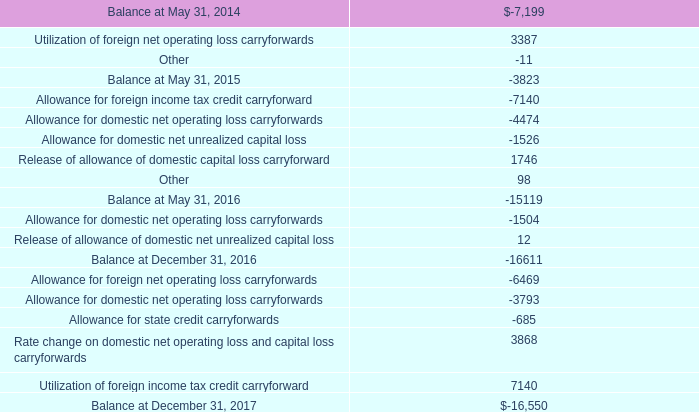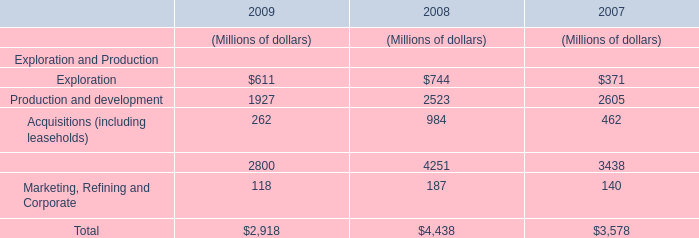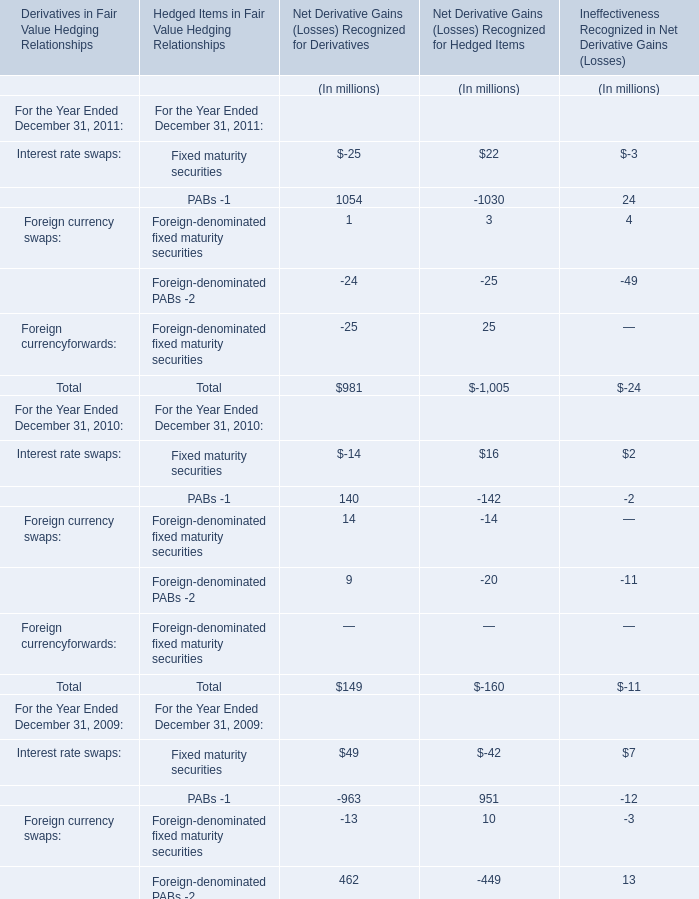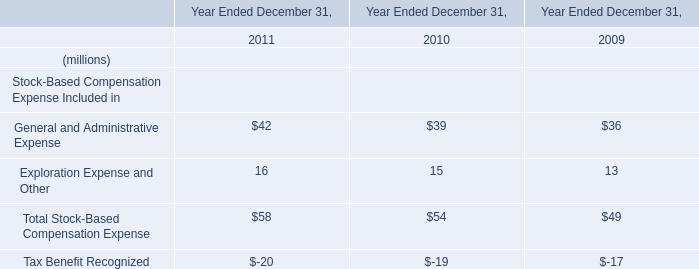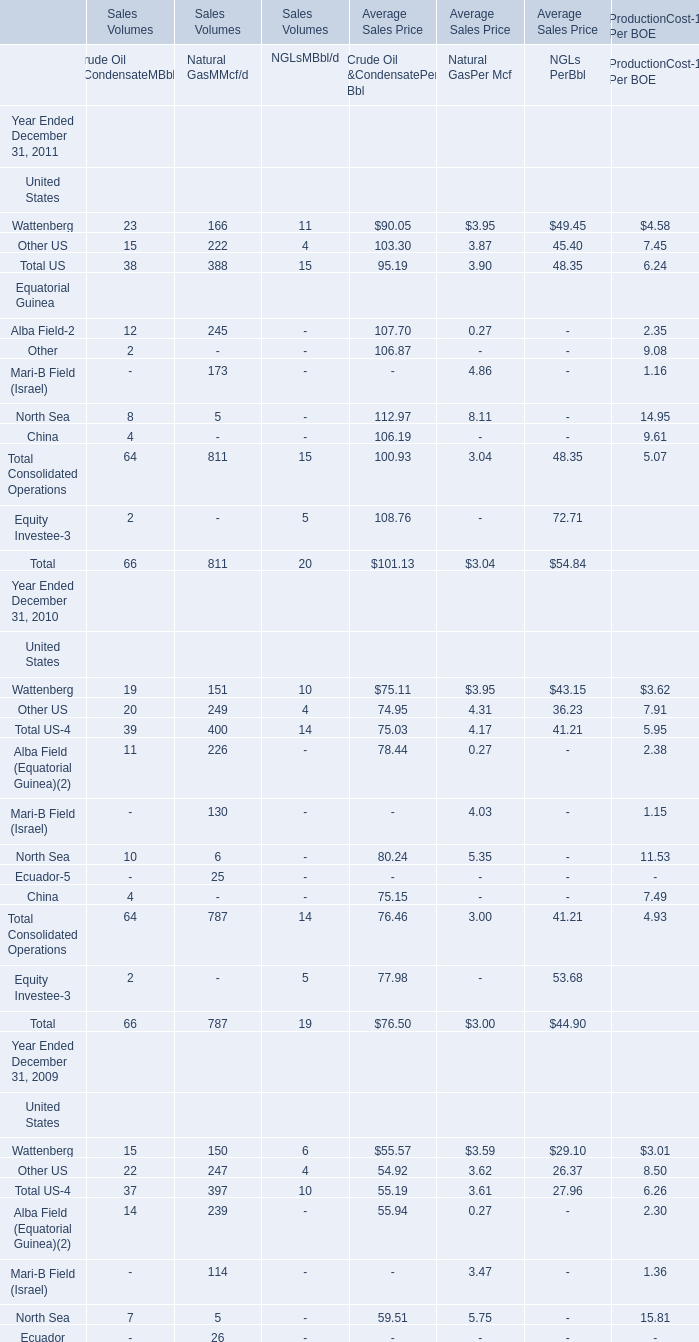In the year with largest amount of Foreign-denominated PABs -2, what's the increasing rate of Fixed maturity securities? 
Computations: ((((-14 + 16) + 2) - ((49 - 42) + 7)) / ((49 - 42) + 7))
Answer: -0.71429. 